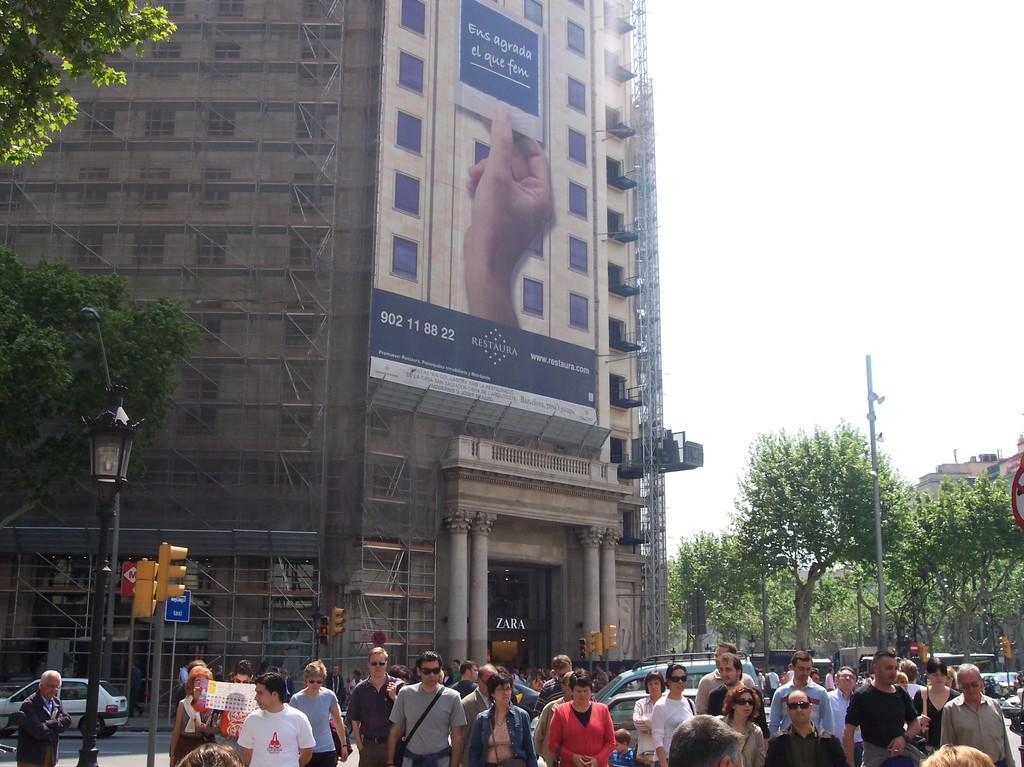How would you summarize this image in a sentence or two? In this picture we can see group of people, few people wore spectacles, behind to them we can find few poles, lights, sign boards and vehicles, and also we can see few buildings, trees and a hoarding. 